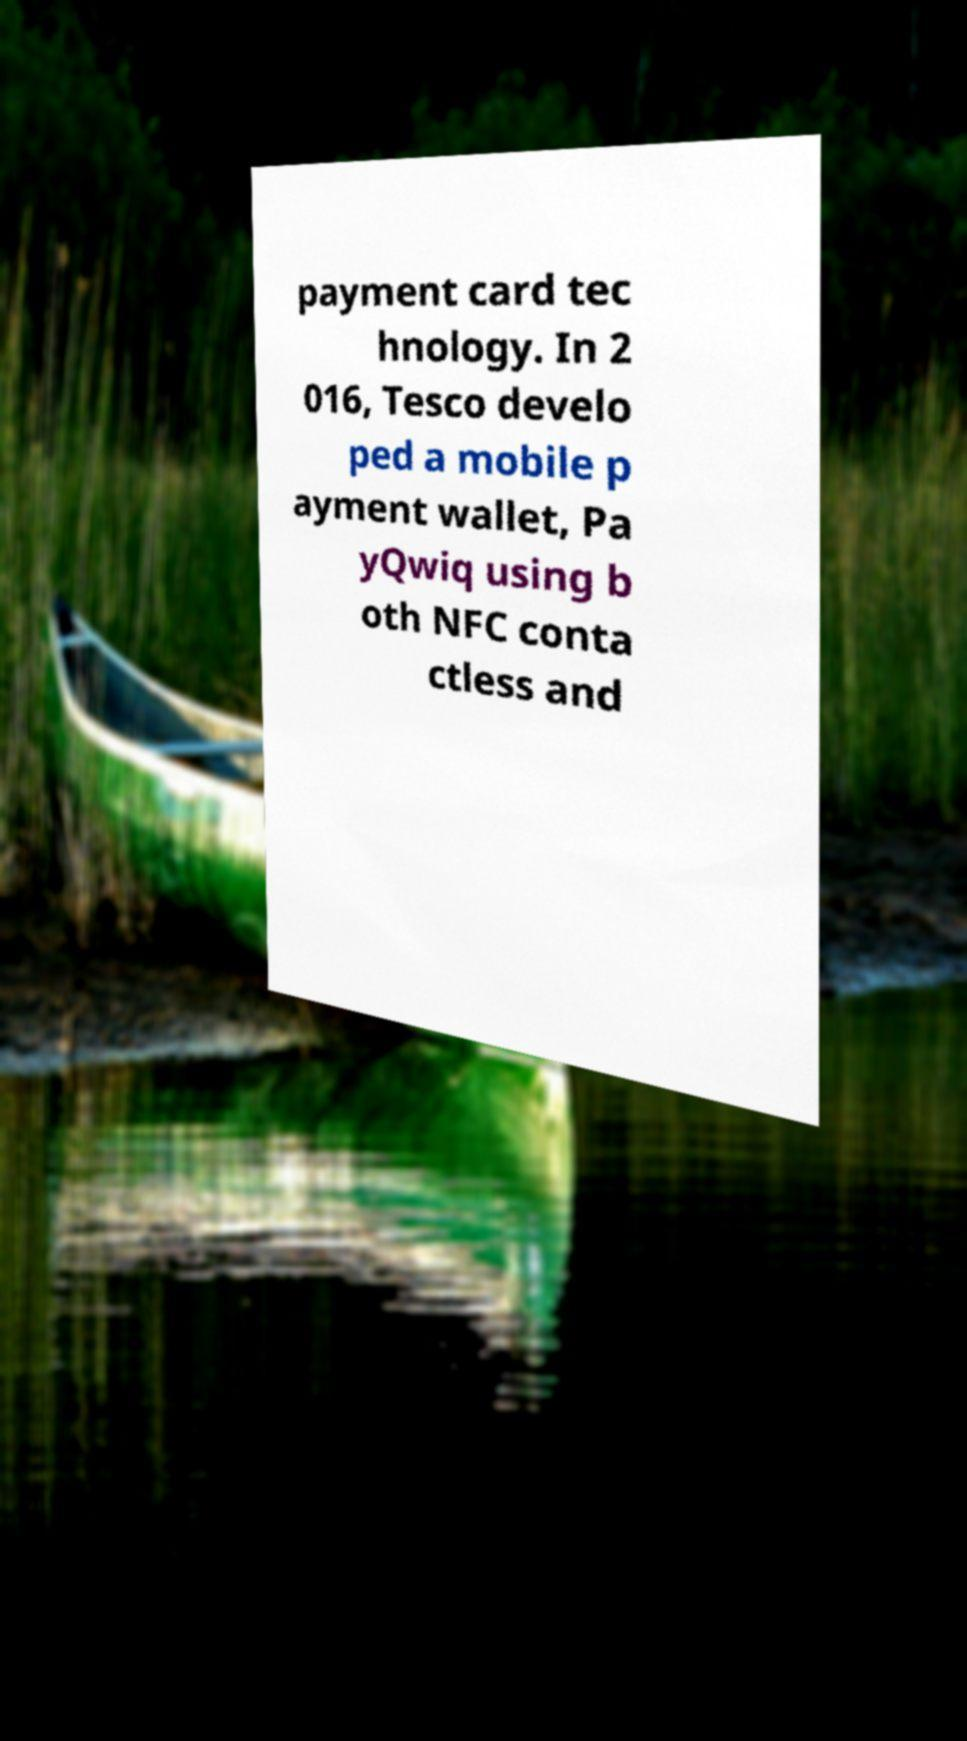Can you accurately transcribe the text from the provided image for me? payment card tec hnology. In 2 016, Tesco develo ped a mobile p ayment wallet, Pa yQwiq using b oth NFC conta ctless and 